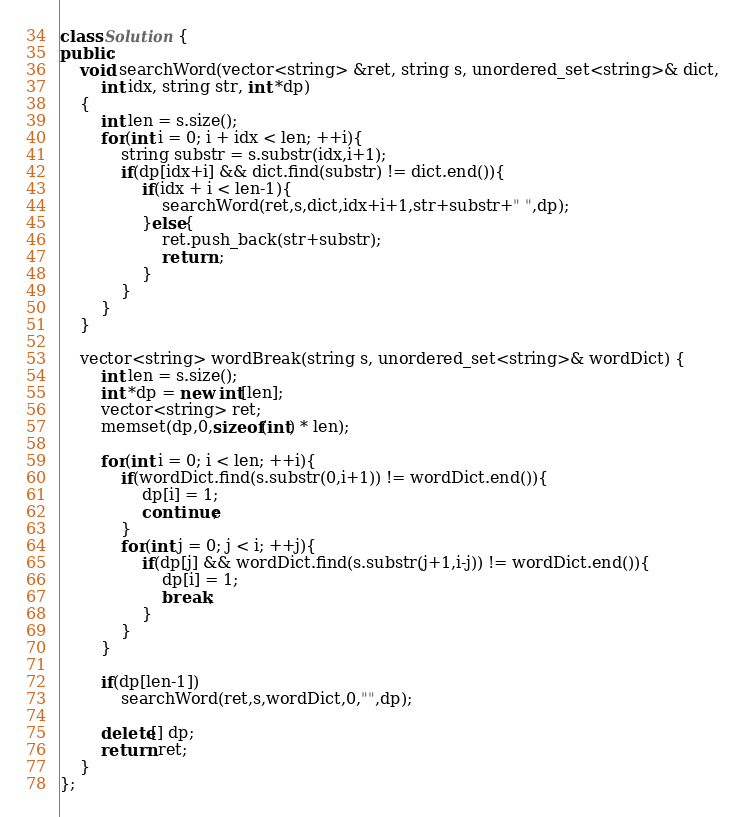Convert code to text. <code><loc_0><loc_0><loc_500><loc_500><_C++_>class Solution {
public:
    void searchWord(vector<string> &ret, string s, unordered_set<string>& dict,
        int idx, string str, int *dp)
    {
        int len = s.size();
        for(int i = 0; i + idx < len; ++i){
            string substr = s.substr(idx,i+1);
            if(dp[idx+i] && dict.find(substr) != dict.end()){
                if(idx + i < len-1){
                    searchWord(ret,s,dict,idx+i+1,str+substr+" ",dp);
                }else{
                    ret.push_back(str+substr);
                    return ;
                }
            }
        }
    }

    vector<string> wordBreak(string s, unordered_set<string>& wordDict) {
        int len = s.size();
        int *dp = new int[len];
        vector<string> ret;
        memset(dp,0,sizeof(int) * len);

        for(int i = 0; i < len; ++i){
            if(wordDict.find(s.substr(0,i+1)) != wordDict.end()){
                dp[i] = 1;
                continue;
            }
            for(int j = 0; j < i; ++j){
                if(dp[j] && wordDict.find(s.substr(j+1,i-j)) != wordDict.end()){
                    dp[i] = 1;
                    break;
                }
            }
        }

        if(dp[len-1])
            searchWord(ret,s,wordDict,0,"",dp);

        delete[] dp;
        return ret;
    }
};
</code> 